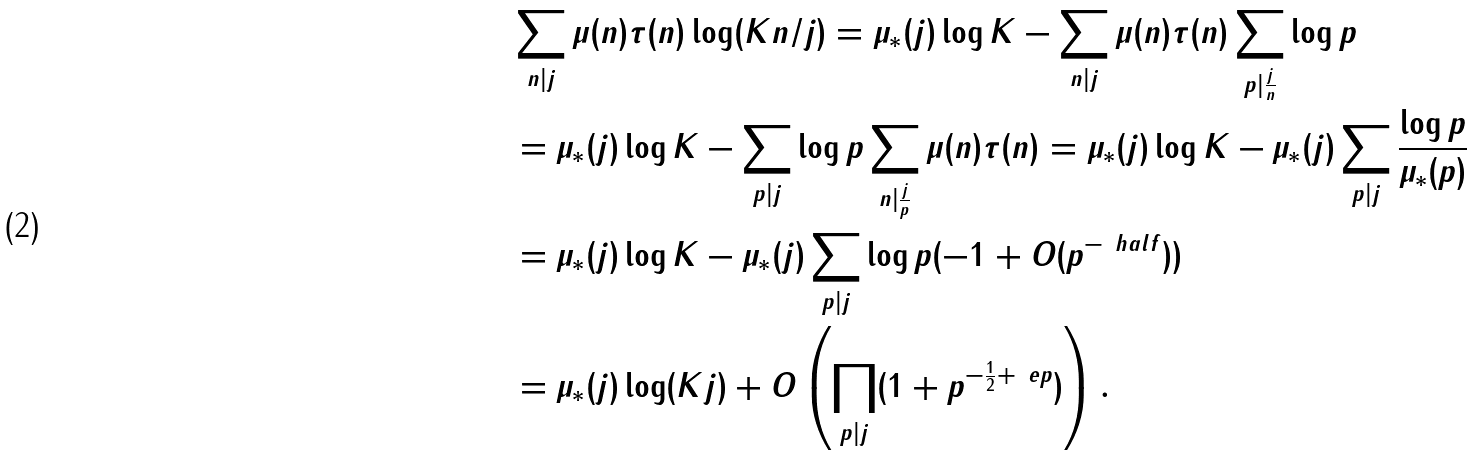<formula> <loc_0><loc_0><loc_500><loc_500>& \sum _ { n | j } \mu ( n ) \tau ( n ) \log ( K n / j ) = \mu _ { * } ( j ) \log K - \sum _ { n | j } \mu ( n ) \tau ( n ) \sum _ { p | \frac { j } { n } } \log p \\ & = \mu _ { * } ( j ) \log K - \sum _ { p | j } \log p \sum _ { n | \frac { j } { p } } \mu ( n ) \tau ( n ) = \mu _ { * } ( j ) \log K - \mu _ { * } ( j ) \sum _ { p | j } \frac { \log p } { \mu _ { * } ( p ) } \\ & = \mu _ { * } ( j ) \log K - \mu _ { * } ( j ) \sum _ { p | j } \log p ( - 1 + O ( p ^ { - \ h a l f } ) ) \\ & = \mu _ { * } ( j ) \log ( K j ) + O \left ( \prod _ { p | j } ( 1 + p ^ { - \frac { 1 } { 2 } + \ e p } ) \right ) .</formula> 